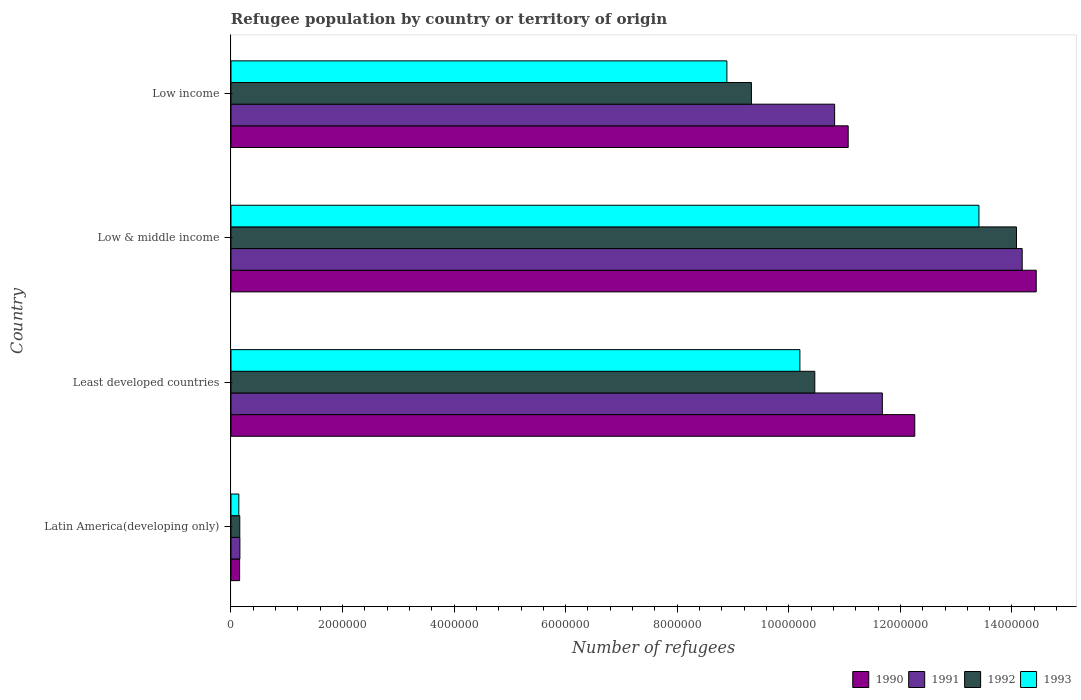How many different coloured bars are there?
Your answer should be very brief. 4. How many groups of bars are there?
Your answer should be very brief. 4. Are the number of bars per tick equal to the number of legend labels?
Offer a very short reply. Yes. Are the number of bars on each tick of the Y-axis equal?
Give a very brief answer. Yes. How many bars are there on the 1st tick from the top?
Give a very brief answer. 4. How many bars are there on the 1st tick from the bottom?
Offer a very short reply. 4. What is the label of the 3rd group of bars from the top?
Give a very brief answer. Least developed countries. What is the number of refugees in 1992 in Low income?
Offer a very short reply. 9.33e+06. Across all countries, what is the maximum number of refugees in 1992?
Ensure brevity in your answer.  1.41e+07. Across all countries, what is the minimum number of refugees in 1992?
Your answer should be compact. 1.58e+05. In which country was the number of refugees in 1992 minimum?
Ensure brevity in your answer.  Latin America(developing only). What is the total number of refugees in 1993 in the graph?
Your response must be concise. 3.26e+07. What is the difference between the number of refugees in 1992 in Least developed countries and that in Low income?
Give a very brief answer. 1.14e+06. What is the difference between the number of refugees in 1992 in Latin America(developing only) and the number of refugees in 1990 in Low & middle income?
Make the answer very short. -1.43e+07. What is the average number of refugees in 1991 per country?
Offer a terse response. 9.21e+06. What is the difference between the number of refugees in 1993 and number of refugees in 1991 in Least developed countries?
Your answer should be very brief. -1.48e+06. What is the ratio of the number of refugees in 1993 in Least developed countries to that in Low & middle income?
Your answer should be compact. 0.76. Is the number of refugees in 1991 in Latin America(developing only) less than that in Low income?
Provide a succinct answer. Yes. Is the difference between the number of refugees in 1993 in Least developed countries and Low income greater than the difference between the number of refugees in 1991 in Least developed countries and Low income?
Make the answer very short. Yes. What is the difference between the highest and the second highest number of refugees in 1990?
Provide a short and direct response. 2.18e+06. What is the difference between the highest and the lowest number of refugees in 1993?
Provide a short and direct response. 1.33e+07. Is the sum of the number of refugees in 1993 in Latin America(developing only) and Low & middle income greater than the maximum number of refugees in 1992 across all countries?
Make the answer very short. No. Are all the bars in the graph horizontal?
Your response must be concise. Yes. How many countries are there in the graph?
Keep it short and to the point. 4. What is the difference between two consecutive major ticks on the X-axis?
Offer a very short reply. 2.00e+06. Does the graph contain grids?
Make the answer very short. No. Where does the legend appear in the graph?
Your answer should be compact. Bottom right. How many legend labels are there?
Make the answer very short. 4. What is the title of the graph?
Make the answer very short. Refugee population by country or territory of origin. Does "1975" appear as one of the legend labels in the graph?
Ensure brevity in your answer.  No. What is the label or title of the X-axis?
Keep it short and to the point. Number of refugees. What is the Number of refugees of 1990 in Latin America(developing only)?
Offer a very short reply. 1.55e+05. What is the Number of refugees of 1991 in Latin America(developing only)?
Your answer should be very brief. 1.60e+05. What is the Number of refugees in 1992 in Latin America(developing only)?
Your answer should be compact. 1.58e+05. What is the Number of refugees in 1993 in Latin America(developing only)?
Your answer should be compact. 1.41e+05. What is the Number of refugees of 1990 in Least developed countries?
Provide a succinct answer. 1.23e+07. What is the Number of refugees in 1991 in Least developed countries?
Offer a very short reply. 1.17e+07. What is the Number of refugees in 1992 in Least developed countries?
Your answer should be very brief. 1.05e+07. What is the Number of refugees of 1993 in Least developed countries?
Provide a short and direct response. 1.02e+07. What is the Number of refugees of 1990 in Low & middle income?
Your answer should be very brief. 1.44e+07. What is the Number of refugees in 1991 in Low & middle income?
Your response must be concise. 1.42e+07. What is the Number of refugees of 1992 in Low & middle income?
Offer a terse response. 1.41e+07. What is the Number of refugees in 1993 in Low & middle income?
Your answer should be very brief. 1.34e+07. What is the Number of refugees in 1990 in Low income?
Offer a very short reply. 1.11e+07. What is the Number of refugees of 1991 in Low income?
Your response must be concise. 1.08e+07. What is the Number of refugees in 1992 in Low income?
Your response must be concise. 9.33e+06. What is the Number of refugees of 1993 in Low income?
Ensure brevity in your answer.  8.89e+06. Across all countries, what is the maximum Number of refugees in 1990?
Make the answer very short. 1.44e+07. Across all countries, what is the maximum Number of refugees of 1991?
Your answer should be very brief. 1.42e+07. Across all countries, what is the maximum Number of refugees in 1992?
Offer a very short reply. 1.41e+07. Across all countries, what is the maximum Number of refugees of 1993?
Provide a short and direct response. 1.34e+07. Across all countries, what is the minimum Number of refugees in 1990?
Your answer should be compact. 1.55e+05. Across all countries, what is the minimum Number of refugees of 1991?
Make the answer very short. 1.60e+05. Across all countries, what is the minimum Number of refugees in 1992?
Make the answer very short. 1.58e+05. Across all countries, what is the minimum Number of refugees in 1993?
Provide a short and direct response. 1.41e+05. What is the total Number of refugees of 1990 in the graph?
Make the answer very short. 3.79e+07. What is the total Number of refugees in 1991 in the graph?
Give a very brief answer. 3.68e+07. What is the total Number of refugees of 1992 in the graph?
Your response must be concise. 3.40e+07. What is the total Number of refugees in 1993 in the graph?
Ensure brevity in your answer.  3.26e+07. What is the difference between the Number of refugees in 1990 in Latin America(developing only) and that in Least developed countries?
Provide a succinct answer. -1.21e+07. What is the difference between the Number of refugees of 1991 in Latin America(developing only) and that in Least developed countries?
Provide a short and direct response. -1.15e+07. What is the difference between the Number of refugees in 1992 in Latin America(developing only) and that in Least developed countries?
Make the answer very short. -1.03e+07. What is the difference between the Number of refugees of 1993 in Latin America(developing only) and that in Least developed countries?
Make the answer very short. -1.01e+07. What is the difference between the Number of refugees of 1990 in Latin America(developing only) and that in Low & middle income?
Your response must be concise. -1.43e+07. What is the difference between the Number of refugees in 1991 in Latin America(developing only) and that in Low & middle income?
Your answer should be compact. -1.40e+07. What is the difference between the Number of refugees in 1992 in Latin America(developing only) and that in Low & middle income?
Ensure brevity in your answer.  -1.39e+07. What is the difference between the Number of refugees in 1993 in Latin America(developing only) and that in Low & middle income?
Your response must be concise. -1.33e+07. What is the difference between the Number of refugees in 1990 in Latin America(developing only) and that in Low income?
Your answer should be very brief. -1.09e+07. What is the difference between the Number of refugees of 1991 in Latin America(developing only) and that in Low income?
Keep it short and to the point. -1.07e+07. What is the difference between the Number of refugees in 1992 in Latin America(developing only) and that in Low income?
Offer a terse response. -9.17e+06. What is the difference between the Number of refugees in 1993 in Latin America(developing only) and that in Low income?
Your response must be concise. -8.75e+06. What is the difference between the Number of refugees in 1990 in Least developed countries and that in Low & middle income?
Give a very brief answer. -2.18e+06. What is the difference between the Number of refugees in 1991 in Least developed countries and that in Low & middle income?
Keep it short and to the point. -2.51e+06. What is the difference between the Number of refugees in 1992 in Least developed countries and that in Low & middle income?
Offer a terse response. -3.62e+06. What is the difference between the Number of refugees in 1993 in Least developed countries and that in Low & middle income?
Offer a terse response. -3.21e+06. What is the difference between the Number of refugees of 1990 in Least developed countries and that in Low income?
Offer a very short reply. 1.19e+06. What is the difference between the Number of refugees of 1991 in Least developed countries and that in Low income?
Keep it short and to the point. 8.55e+05. What is the difference between the Number of refugees in 1992 in Least developed countries and that in Low income?
Your response must be concise. 1.14e+06. What is the difference between the Number of refugees in 1993 in Least developed countries and that in Low income?
Provide a succinct answer. 1.31e+06. What is the difference between the Number of refugees in 1990 in Low & middle income and that in Low income?
Give a very brief answer. 3.37e+06. What is the difference between the Number of refugees in 1991 in Low & middle income and that in Low income?
Make the answer very short. 3.36e+06. What is the difference between the Number of refugees of 1992 in Low & middle income and that in Low income?
Your response must be concise. 4.75e+06. What is the difference between the Number of refugees of 1993 in Low & middle income and that in Low income?
Your response must be concise. 4.52e+06. What is the difference between the Number of refugees in 1990 in Latin America(developing only) and the Number of refugees in 1991 in Least developed countries?
Your answer should be very brief. -1.15e+07. What is the difference between the Number of refugees in 1990 in Latin America(developing only) and the Number of refugees in 1992 in Least developed countries?
Your answer should be compact. -1.03e+07. What is the difference between the Number of refugees in 1990 in Latin America(developing only) and the Number of refugees in 1993 in Least developed countries?
Offer a terse response. -1.00e+07. What is the difference between the Number of refugees in 1991 in Latin America(developing only) and the Number of refugees in 1992 in Least developed countries?
Give a very brief answer. -1.03e+07. What is the difference between the Number of refugees of 1991 in Latin America(developing only) and the Number of refugees of 1993 in Least developed countries?
Your response must be concise. -1.00e+07. What is the difference between the Number of refugees of 1992 in Latin America(developing only) and the Number of refugees of 1993 in Least developed countries?
Ensure brevity in your answer.  -1.00e+07. What is the difference between the Number of refugees in 1990 in Latin America(developing only) and the Number of refugees in 1991 in Low & middle income?
Make the answer very short. -1.40e+07. What is the difference between the Number of refugees of 1990 in Latin America(developing only) and the Number of refugees of 1992 in Low & middle income?
Provide a short and direct response. -1.39e+07. What is the difference between the Number of refugees in 1990 in Latin America(developing only) and the Number of refugees in 1993 in Low & middle income?
Your answer should be very brief. -1.33e+07. What is the difference between the Number of refugees of 1991 in Latin America(developing only) and the Number of refugees of 1992 in Low & middle income?
Your answer should be very brief. -1.39e+07. What is the difference between the Number of refugees in 1991 in Latin America(developing only) and the Number of refugees in 1993 in Low & middle income?
Give a very brief answer. -1.32e+07. What is the difference between the Number of refugees of 1992 in Latin America(developing only) and the Number of refugees of 1993 in Low & middle income?
Provide a succinct answer. -1.33e+07. What is the difference between the Number of refugees of 1990 in Latin America(developing only) and the Number of refugees of 1991 in Low income?
Your answer should be very brief. -1.07e+07. What is the difference between the Number of refugees of 1990 in Latin America(developing only) and the Number of refugees of 1992 in Low income?
Offer a terse response. -9.17e+06. What is the difference between the Number of refugees of 1990 in Latin America(developing only) and the Number of refugees of 1993 in Low income?
Provide a short and direct response. -8.74e+06. What is the difference between the Number of refugees in 1991 in Latin America(developing only) and the Number of refugees in 1992 in Low income?
Make the answer very short. -9.17e+06. What is the difference between the Number of refugees in 1991 in Latin America(developing only) and the Number of refugees in 1993 in Low income?
Keep it short and to the point. -8.73e+06. What is the difference between the Number of refugees in 1992 in Latin America(developing only) and the Number of refugees in 1993 in Low income?
Offer a terse response. -8.73e+06. What is the difference between the Number of refugees in 1990 in Least developed countries and the Number of refugees in 1991 in Low & middle income?
Provide a succinct answer. -1.93e+06. What is the difference between the Number of refugees of 1990 in Least developed countries and the Number of refugees of 1992 in Low & middle income?
Offer a terse response. -1.82e+06. What is the difference between the Number of refugees in 1990 in Least developed countries and the Number of refugees in 1993 in Low & middle income?
Keep it short and to the point. -1.15e+06. What is the difference between the Number of refugees of 1991 in Least developed countries and the Number of refugees of 1992 in Low & middle income?
Provide a short and direct response. -2.40e+06. What is the difference between the Number of refugees in 1991 in Least developed countries and the Number of refugees in 1993 in Low & middle income?
Offer a very short reply. -1.73e+06. What is the difference between the Number of refugees in 1992 in Least developed countries and the Number of refugees in 1993 in Low & middle income?
Make the answer very short. -2.94e+06. What is the difference between the Number of refugees of 1990 in Least developed countries and the Number of refugees of 1991 in Low income?
Offer a very short reply. 1.44e+06. What is the difference between the Number of refugees of 1990 in Least developed countries and the Number of refugees of 1992 in Low income?
Your response must be concise. 2.93e+06. What is the difference between the Number of refugees in 1990 in Least developed countries and the Number of refugees in 1993 in Low income?
Your answer should be very brief. 3.37e+06. What is the difference between the Number of refugees in 1991 in Least developed countries and the Number of refugees in 1992 in Low income?
Ensure brevity in your answer.  2.35e+06. What is the difference between the Number of refugees of 1991 in Least developed countries and the Number of refugees of 1993 in Low income?
Your answer should be compact. 2.79e+06. What is the difference between the Number of refugees of 1992 in Least developed countries and the Number of refugees of 1993 in Low income?
Make the answer very short. 1.58e+06. What is the difference between the Number of refugees in 1990 in Low & middle income and the Number of refugees in 1991 in Low income?
Make the answer very short. 3.61e+06. What is the difference between the Number of refugees of 1990 in Low & middle income and the Number of refugees of 1992 in Low income?
Offer a terse response. 5.11e+06. What is the difference between the Number of refugees of 1990 in Low & middle income and the Number of refugees of 1993 in Low income?
Your answer should be compact. 5.55e+06. What is the difference between the Number of refugees in 1991 in Low & middle income and the Number of refugees in 1992 in Low income?
Your answer should be very brief. 4.85e+06. What is the difference between the Number of refugees in 1991 in Low & middle income and the Number of refugees in 1993 in Low income?
Ensure brevity in your answer.  5.29e+06. What is the difference between the Number of refugees in 1992 in Low & middle income and the Number of refugees in 1993 in Low income?
Your response must be concise. 5.19e+06. What is the average Number of refugees of 1990 per country?
Your answer should be compact. 9.48e+06. What is the average Number of refugees in 1991 per country?
Provide a short and direct response. 9.21e+06. What is the average Number of refugees in 1992 per country?
Make the answer very short. 8.51e+06. What is the average Number of refugees in 1993 per country?
Give a very brief answer. 8.16e+06. What is the difference between the Number of refugees of 1990 and Number of refugees of 1991 in Latin America(developing only)?
Your answer should be compact. -4784. What is the difference between the Number of refugees in 1990 and Number of refugees in 1992 in Latin America(developing only)?
Provide a succinct answer. -2704. What is the difference between the Number of refugees in 1990 and Number of refugees in 1993 in Latin America(developing only)?
Your answer should be very brief. 1.42e+04. What is the difference between the Number of refugees in 1991 and Number of refugees in 1992 in Latin America(developing only)?
Keep it short and to the point. 2080. What is the difference between the Number of refugees in 1991 and Number of refugees in 1993 in Latin America(developing only)?
Make the answer very short. 1.89e+04. What is the difference between the Number of refugees of 1992 and Number of refugees of 1993 in Latin America(developing only)?
Your answer should be very brief. 1.69e+04. What is the difference between the Number of refugees in 1990 and Number of refugees in 1991 in Least developed countries?
Keep it short and to the point. 5.82e+05. What is the difference between the Number of refugees in 1990 and Number of refugees in 1992 in Least developed countries?
Keep it short and to the point. 1.79e+06. What is the difference between the Number of refugees in 1990 and Number of refugees in 1993 in Least developed countries?
Give a very brief answer. 2.06e+06. What is the difference between the Number of refugees in 1991 and Number of refugees in 1992 in Least developed countries?
Your response must be concise. 1.21e+06. What is the difference between the Number of refugees in 1991 and Number of refugees in 1993 in Least developed countries?
Your answer should be very brief. 1.48e+06. What is the difference between the Number of refugees in 1992 and Number of refugees in 1993 in Least developed countries?
Your answer should be compact. 2.67e+05. What is the difference between the Number of refugees in 1990 and Number of refugees in 1991 in Low & middle income?
Make the answer very short. 2.52e+05. What is the difference between the Number of refugees of 1990 and Number of refugees of 1992 in Low & middle income?
Ensure brevity in your answer.  3.54e+05. What is the difference between the Number of refugees of 1990 and Number of refugees of 1993 in Low & middle income?
Give a very brief answer. 1.03e+06. What is the difference between the Number of refugees of 1991 and Number of refugees of 1992 in Low & middle income?
Keep it short and to the point. 1.02e+05. What is the difference between the Number of refugees of 1991 and Number of refugees of 1993 in Low & middle income?
Keep it short and to the point. 7.75e+05. What is the difference between the Number of refugees in 1992 and Number of refugees in 1993 in Low & middle income?
Your response must be concise. 6.73e+05. What is the difference between the Number of refugees in 1990 and Number of refugees in 1991 in Low income?
Make the answer very short. 2.43e+05. What is the difference between the Number of refugees of 1990 and Number of refugees of 1992 in Low income?
Ensure brevity in your answer.  1.73e+06. What is the difference between the Number of refugees of 1990 and Number of refugees of 1993 in Low income?
Make the answer very short. 2.17e+06. What is the difference between the Number of refugees in 1991 and Number of refugees in 1992 in Low income?
Make the answer very short. 1.49e+06. What is the difference between the Number of refugees in 1991 and Number of refugees in 1993 in Low income?
Your response must be concise. 1.93e+06. What is the difference between the Number of refugees of 1992 and Number of refugees of 1993 in Low income?
Your answer should be compact. 4.40e+05. What is the ratio of the Number of refugees of 1990 in Latin America(developing only) to that in Least developed countries?
Provide a succinct answer. 0.01. What is the ratio of the Number of refugees in 1991 in Latin America(developing only) to that in Least developed countries?
Your answer should be compact. 0.01. What is the ratio of the Number of refugees in 1992 in Latin America(developing only) to that in Least developed countries?
Make the answer very short. 0.02. What is the ratio of the Number of refugees of 1993 in Latin America(developing only) to that in Least developed countries?
Provide a succinct answer. 0.01. What is the ratio of the Number of refugees of 1990 in Latin America(developing only) to that in Low & middle income?
Provide a succinct answer. 0.01. What is the ratio of the Number of refugees of 1991 in Latin America(developing only) to that in Low & middle income?
Offer a terse response. 0.01. What is the ratio of the Number of refugees in 1992 in Latin America(developing only) to that in Low & middle income?
Provide a succinct answer. 0.01. What is the ratio of the Number of refugees of 1993 in Latin America(developing only) to that in Low & middle income?
Provide a succinct answer. 0.01. What is the ratio of the Number of refugees of 1990 in Latin America(developing only) to that in Low income?
Offer a very short reply. 0.01. What is the ratio of the Number of refugees of 1991 in Latin America(developing only) to that in Low income?
Ensure brevity in your answer.  0.01. What is the ratio of the Number of refugees in 1992 in Latin America(developing only) to that in Low income?
Your answer should be compact. 0.02. What is the ratio of the Number of refugees in 1993 in Latin America(developing only) to that in Low income?
Ensure brevity in your answer.  0.02. What is the ratio of the Number of refugees in 1990 in Least developed countries to that in Low & middle income?
Your answer should be very brief. 0.85. What is the ratio of the Number of refugees in 1991 in Least developed countries to that in Low & middle income?
Provide a short and direct response. 0.82. What is the ratio of the Number of refugees in 1992 in Least developed countries to that in Low & middle income?
Give a very brief answer. 0.74. What is the ratio of the Number of refugees in 1993 in Least developed countries to that in Low & middle income?
Give a very brief answer. 0.76. What is the ratio of the Number of refugees of 1990 in Least developed countries to that in Low income?
Give a very brief answer. 1.11. What is the ratio of the Number of refugees in 1991 in Least developed countries to that in Low income?
Your answer should be very brief. 1.08. What is the ratio of the Number of refugees of 1992 in Least developed countries to that in Low income?
Ensure brevity in your answer.  1.12. What is the ratio of the Number of refugees of 1993 in Least developed countries to that in Low income?
Make the answer very short. 1.15. What is the ratio of the Number of refugees in 1990 in Low & middle income to that in Low income?
Offer a terse response. 1.3. What is the ratio of the Number of refugees in 1991 in Low & middle income to that in Low income?
Ensure brevity in your answer.  1.31. What is the ratio of the Number of refugees in 1992 in Low & middle income to that in Low income?
Make the answer very short. 1.51. What is the ratio of the Number of refugees in 1993 in Low & middle income to that in Low income?
Your response must be concise. 1.51. What is the difference between the highest and the second highest Number of refugees in 1990?
Make the answer very short. 2.18e+06. What is the difference between the highest and the second highest Number of refugees of 1991?
Offer a terse response. 2.51e+06. What is the difference between the highest and the second highest Number of refugees in 1992?
Offer a terse response. 3.62e+06. What is the difference between the highest and the second highest Number of refugees in 1993?
Keep it short and to the point. 3.21e+06. What is the difference between the highest and the lowest Number of refugees in 1990?
Your response must be concise. 1.43e+07. What is the difference between the highest and the lowest Number of refugees in 1991?
Provide a succinct answer. 1.40e+07. What is the difference between the highest and the lowest Number of refugees in 1992?
Offer a very short reply. 1.39e+07. What is the difference between the highest and the lowest Number of refugees in 1993?
Offer a very short reply. 1.33e+07. 